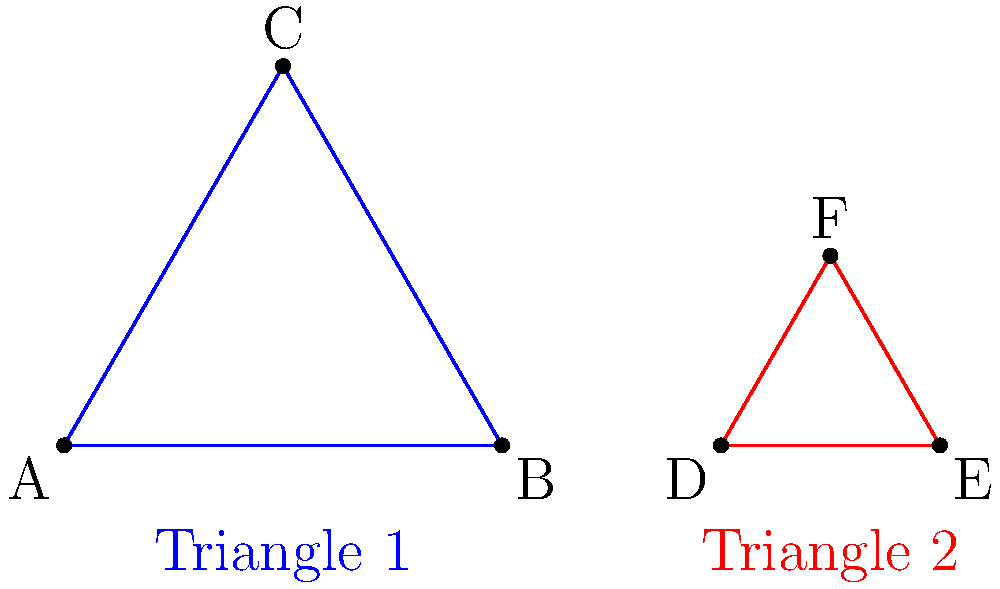In sacred geometry, the equilateral triangle is often used to represent the Holy Trinity. Consider the two equilateral triangles shown above. If Triangle 1 has a side length of 2 units and Triangle 2 has a side length of 1 unit, are these triangles congruent? If not, what transformation would make them congruent? To determine if the triangles are congruent and what transformation might make them congruent, let's follow these steps:

1. Definition of congruence: Two shapes are congruent if they have the same shape and size.

2. Examine the given information:
   - Triangle 1 has a side length of 2 units
   - Triangle 2 has a side length of 1 unit

3. Compare the side lengths:
   - The side lengths are different (2 units vs 1 unit)
   - This means the triangles are not the same size

4. Conclusion on congruence:
   - Since the triangles have different sizes, they are not congruent

5. Transformation to make them congruent:
   - To make Triangle 2 congruent to Triangle 1, we need to enlarge it
   - The scale factor would be: $\frac{\text{Side length of Triangle 1}}{\text{Side length of Triangle 2}} = \frac{2}{1} = 2$

6. The transformation:
   - Apply a dilation with scale factor 2 to Triangle 2
   - This will double its size, making it congruent to Triangle 1

7. Theological reflection:
   - In sacred geometry, this transformation could symbolize the expansion of faith or the growth of the Trinity's influence in one's life
Answer: Not congruent; dilation with scale factor 2 